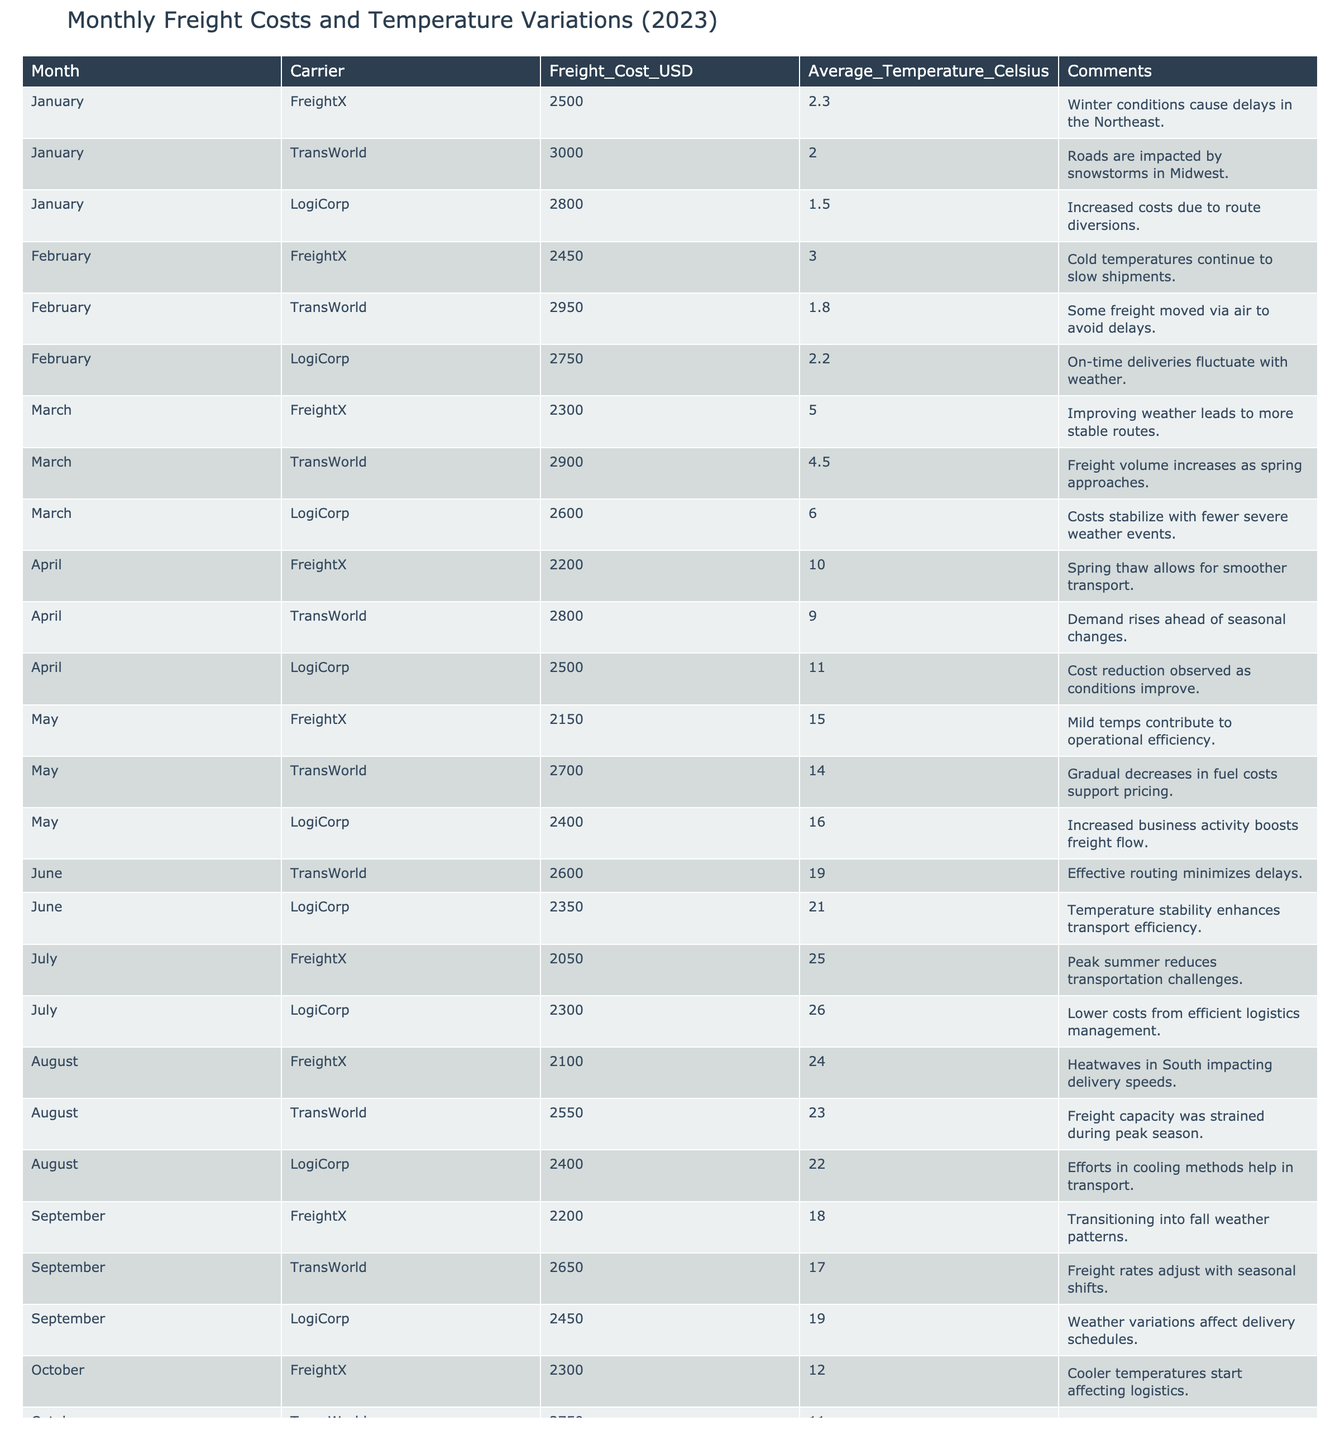What was the highest freight cost in December 2023? The table shows that in December, FreightX had a cost of 3000 USD, TransWorld had 3200 USD, and LogiCorp had 2900 USD. The highest cost is 3200 USD from TransWorld.
Answer: 3200 USD Which carrier had the least freight cost in July 2023? In July, FreightX had a cost of 2050 USD, TransWorld had a cost of 2600 USD, and LogiCorp had a cost of 2300 USD. The least cost is 2050 USD from FreightX.
Answer: FreightX What is the average temperature for the month of May? The table lists the average temperatures for May as 15.0, 14.0, and 16.0 degrees Celsius for FreightX, TransWorld, and LogiCorp, respectively. The average temperature is (15.0 + 14.0 + 16.0) / 3 = 15.0 degrees Celsius.
Answer: 15.0 degrees Celsius Did the freight costs increase from October to December 2023 for all carriers? October freight costs were 2300, 2750, and 2500 USD, respectively, for the carriers, while December costs were 3000, 3200, and 2900 USD, respectively. All costs increased.
Answer: Yes What was the overall trend of freight costs from January to June 2023? In January, the costs were at 2500, 3000, and 2800 USD; by June, they dropped to 2050, 2600, and 2350 USD respectively. The overall trend shows a decrease in freight costs from January to June.
Answer: Decrease What is the difference in average freight costs between the months of March and August? In March, the average costs were (2300 + 2900 + 2600) / 3 = 2600 USD. In August, they were (2100 + 2550 + 2400) / 3 = 2350 USD. The difference is 2600 - 2350 = 250 USD.
Answer: 250 USD How many months had an average temperature below 5 degrees Celsius? The months with temperatures below 5 degrees Celsius are November and December. Counting these gives us 2 months.
Answer: 2 months Which month saw an increase in freight costs for TransWorld compared to the previous month? In June, TransWorld had a cost of 2600 USD, which is a decrease from 2700 USD in May. However, it increased from 2550 USD in August to 2650 USD in September. The overall pattern does not show continued increases but fluctuates.
Answer: No (fluctuates) Was there any carrier that had the same freight cost for consecutive months? Checking the freight costs month-to-month shows no two months with the same freight cost for any carrier. Each month has a unique cost.
Answer: No 